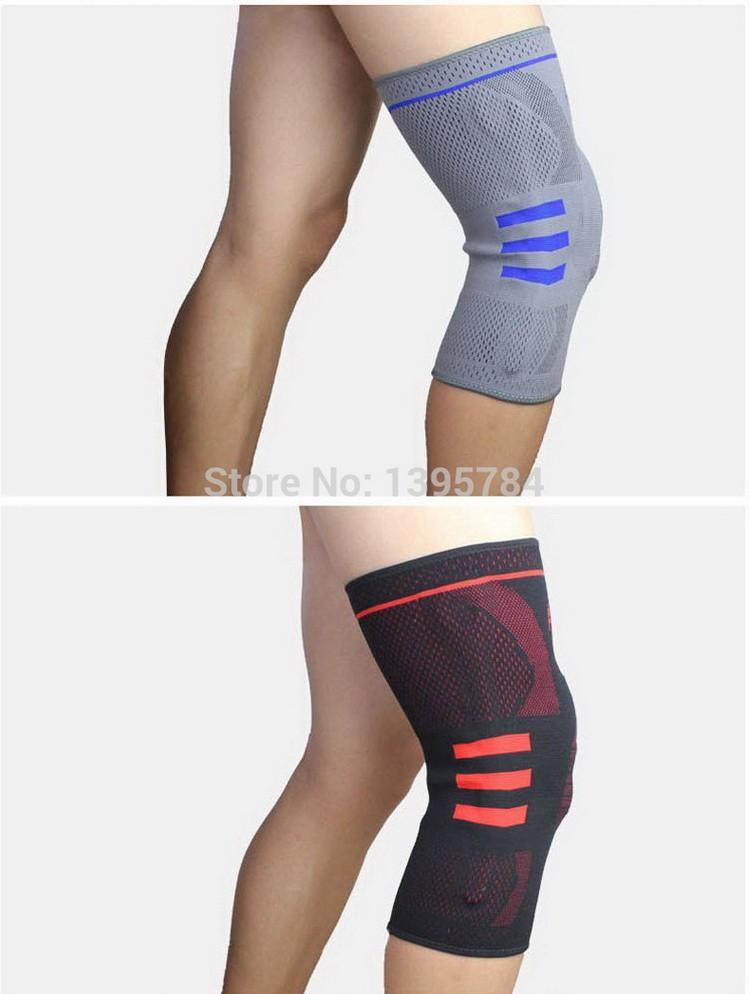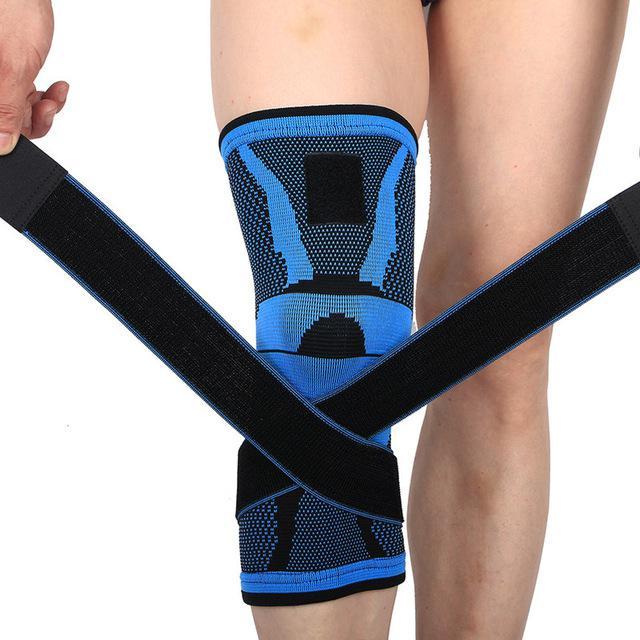The first image is the image on the left, the second image is the image on the right. Considering the images on both sides, is "Every knee pad has a hole at the kneecap area." valid? Answer yes or no. No. The first image is the image on the left, the second image is the image on the right. Assess this claim about the two images: "In each image, a single black kneepad on a human leg is made with a round hole at the center of the knee.". Correct or not? Answer yes or no. No. 